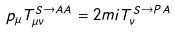<formula> <loc_0><loc_0><loc_500><loc_500>p _ { \mu } T ^ { S \rightarrow A A } _ { \mu \nu } = 2 m i T ^ { S \rightarrow P A } _ { \nu }</formula> 